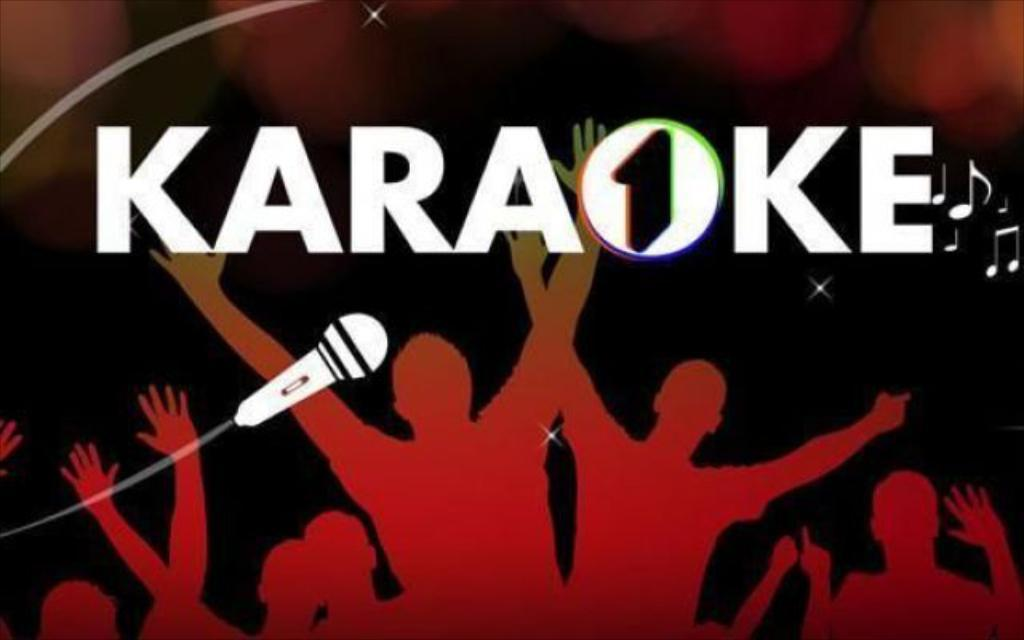Provide a one-sentence caption for the provided image. An illustrated image type advertisement that says, Karaoke. 